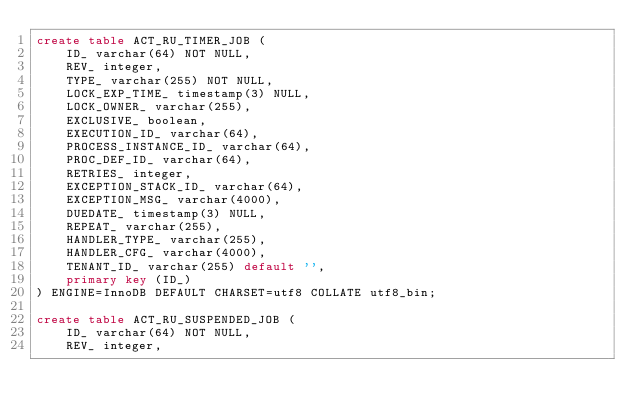Convert code to text. <code><loc_0><loc_0><loc_500><loc_500><_SQL_>create table ACT_RU_TIMER_JOB (
    ID_ varchar(64) NOT NULL,
    REV_ integer,
    TYPE_ varchar(255) NOT NULL,
    LOCK_EXP_TIME_ timestamp(3) NULL,
    LOCK_OWNER_ varchar(255),
    EXCLUSIVE_ boolean,
    EXECUTION_ID_ varchar(64),
    PROCESS_INSTANCE_ID_ varchar(64),
    PROC_DEF_ID_ varchar(64),
    RETRIES_ integer,
    EXCEPTION_STACK_ID_ varchar(64),
    EXCEPTION_MSG_ varchar(4000),
    DUEDATE_ timestamp(3) NULL,
    REPEAT_ varchar(255),
    HANDLER_TYPE_ varchar(255),
    HANDLER_CFG_ varchar(4000),
    TENANT_ID_ varchar(255) default '',
    primary key (ID_)
) ENGINE=InnoDB DEFAULT CHARSET=utf8 COLLATE utf8_bin;

create table ACT_RU_SUSPENDED_JOB (
    ID_ varchar(64) NOT NULL,
    REV_ integer,</code> 